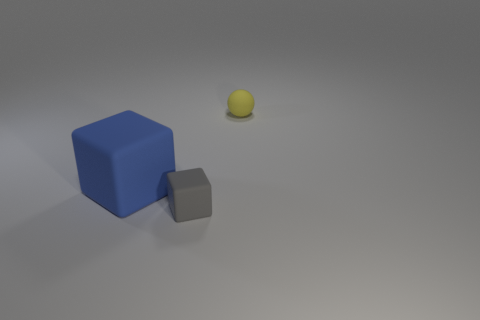There is a thing to the right of the gray block; what is its shape?
Provide a short and direct response. Sphere. Is there anything else that is made of the same material as the blue object?
Your response must be concise. Yes. Are there more big blocks that are right of the large block than big blue balls?
Keep it short and to the point. No. How many things are on the left side of the tiny object in front of the tiny rubber thing that is behind the tiny rubber block?
Provide a succinct answer. 1. There is a cube that is on the right side of the blue matte object; is its size the same as the thing behind the blue cube?
Make the answer very short. Yes. There is a thing that is on the left side of the tiny object that is left of the matte ball; what is its material?
Keep it short and to the point. Rubber. How many things are rubber cubes that are to the right of the large blue rubber object or rubber balls?
Ensure brevity in your answer.  2. Are there an equal number of things in front of the large matte block and tiny spheres on the left side of the tiny yellow matte object?
Ensure brevity in your answer.  No. The object that is in front of the object that is to the left of the block that is in front of the big blue matte thing is made of what material?
Your answer should be very brief. Rubber. How big is the matte thing that is both behind the tiny gray cube and in front of the ball?
Your answer should be very brief. Large. 